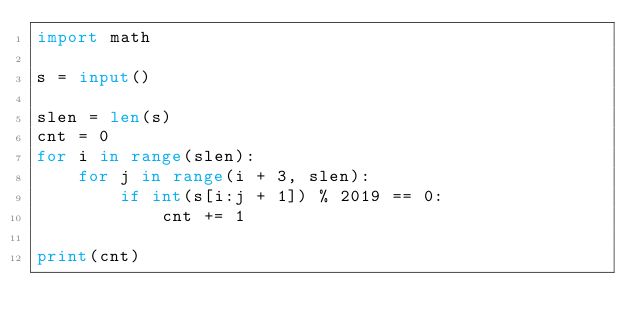<code> <loc_0><loc_0><loc_500><loc_500><_Python_>import math

s = input()

slen = len(s)
cnt = 0
for i in range(slen):
    for j in range(i + 3, slen):
        if int(s[i:j + 1]) % 2019 == 0:
            cnt += 1

print(cnt)</code> 